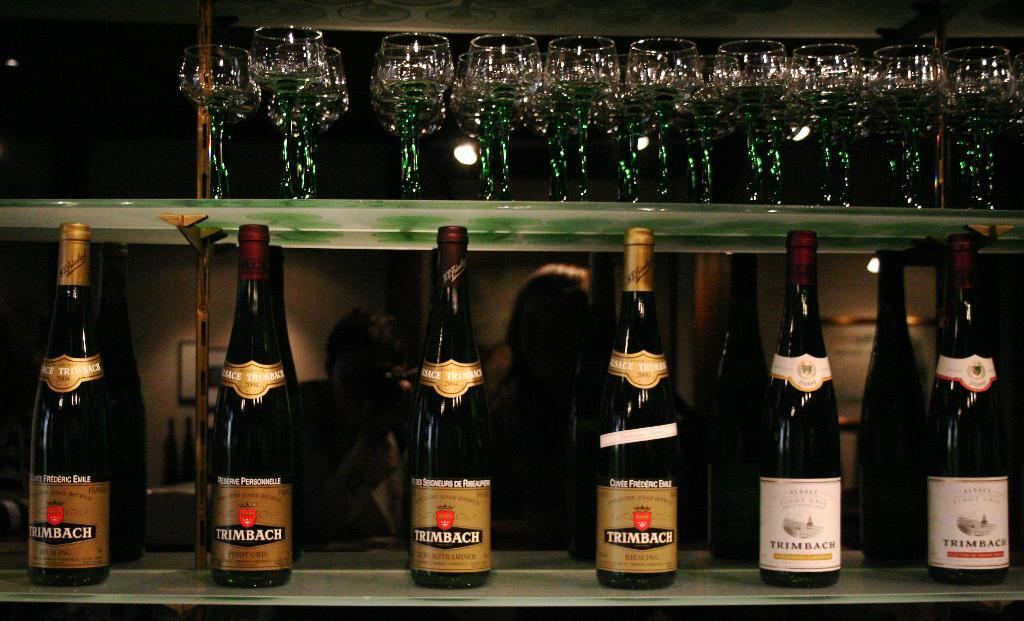<image>
Offer a succinct explanation of the picture presented. Bottles of Trimbach alcohol with gold and white labels. 